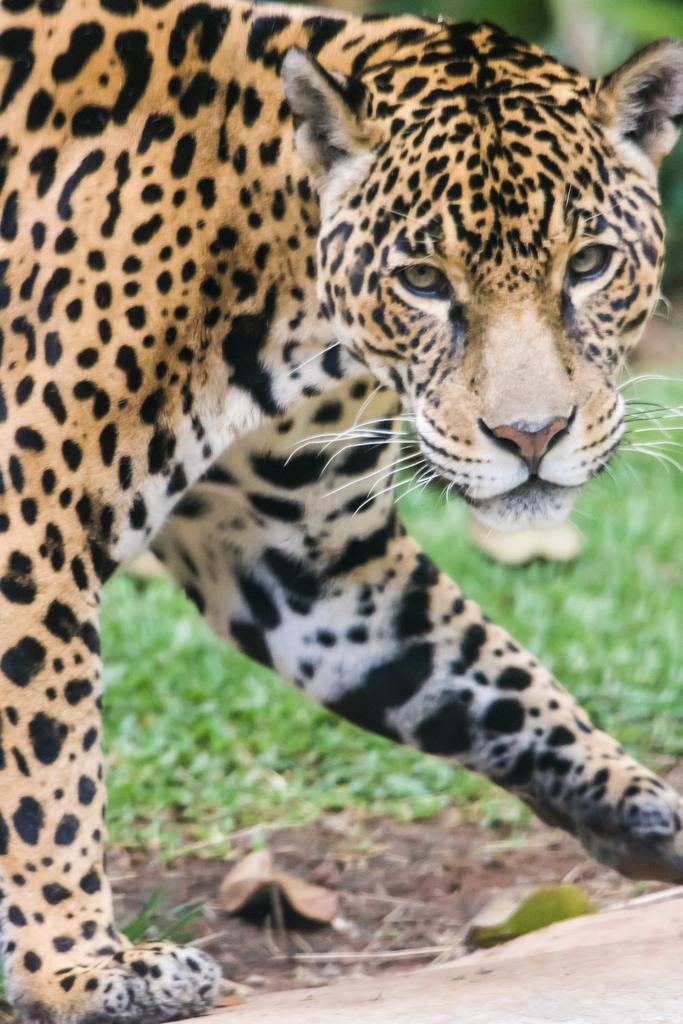Could you give a brief overview of what you see in this image? This image is taken outdoors. At the bottom of the image there is a road. In the background there is a ground with grass on it. In the middle of the image there is a leopard. 